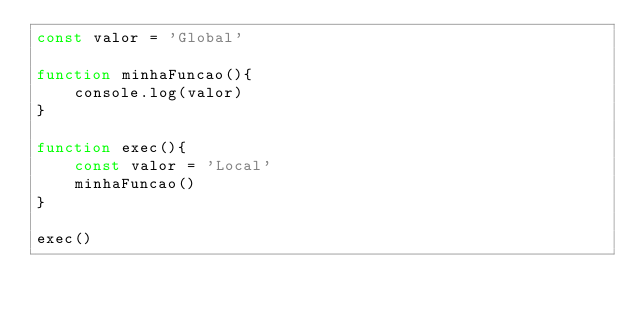Convert code to text. <code><loc_0><loc_0><loc_500><loc_500><_JavaScript_>const valor = 'Global'

function minhaFuncao(){
    console.log(valor)
}

function exec(){
    const valor = 'Local'
    minhaFuncao()
}

exec()</code> 